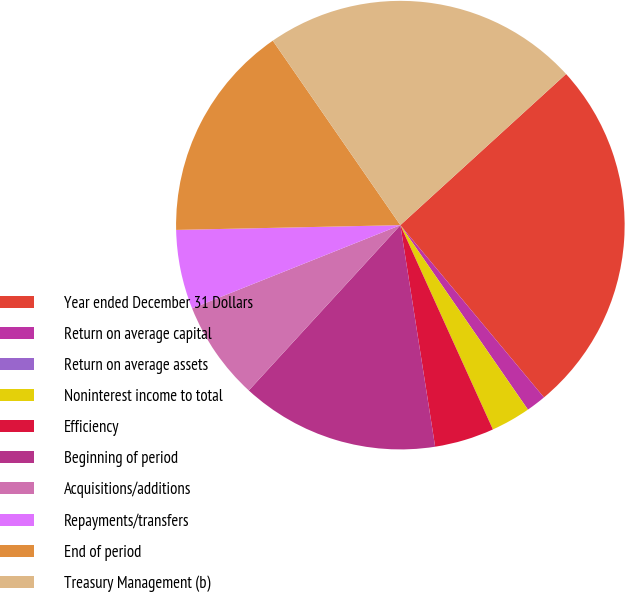Convert chart to OTSL. <chart><loc_0><loc_0><loc_500><loc_500><pie_chart><fcel>Year ended December 31 Dollars<fcel>Return on average capital<fcel>Return on average assets<fcel>Noninterest income to total<fcel>Efficiency<fcel>Beginning of period<fcel>Acquisitions/additions<fcel>Repayments/transfers<fcel>End of period<fcel>Treasury Management (b)<nl><fcel>25.71%<fcel>1.43%<fcel>0.0%<fcel>2.86%<fcel>4.29%<fcel>14.29%<fcel>7.14%<fcel>5.71%<fcel>15.71%<fcel>22.86%<nl></chart> 